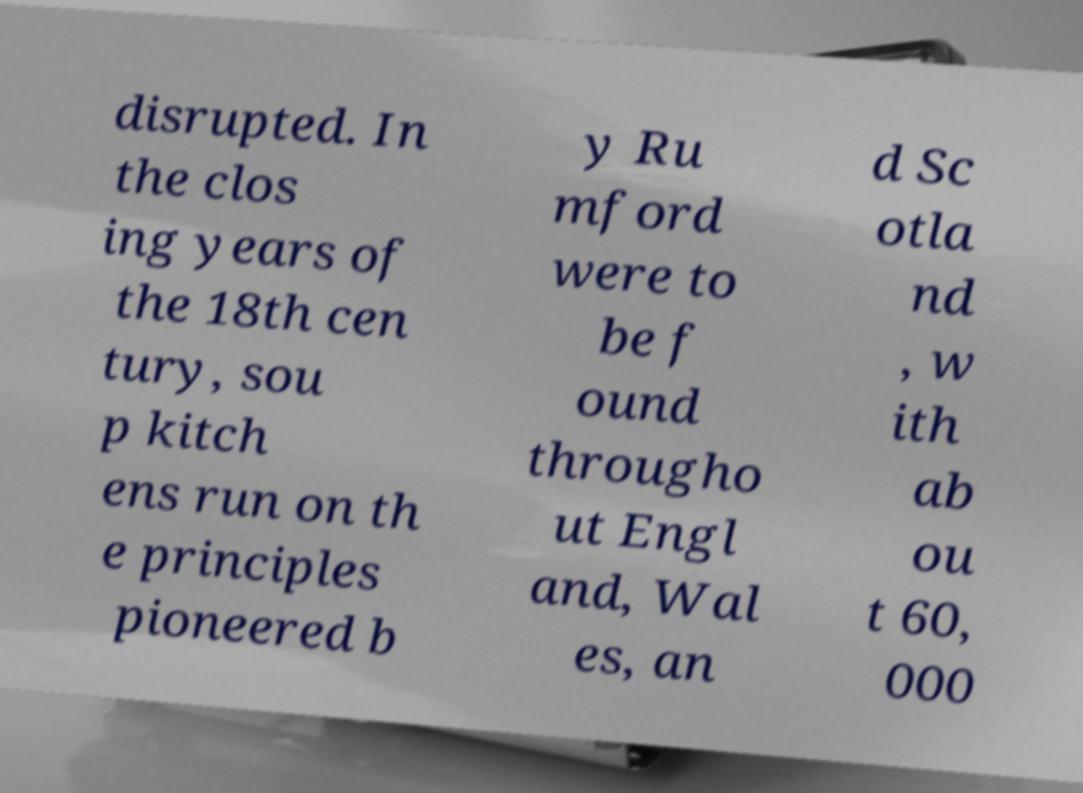Can you accurately transcribe the text from the provided image for me? disrupted. In the clos ing years of the 18th cen tury, sou p kitch ens run on th e principles pioneered b y Ru mford were to be f ound througho ut Engl and, Wal es, an d Sc otla nd , w ith ab ou t 60, 000 